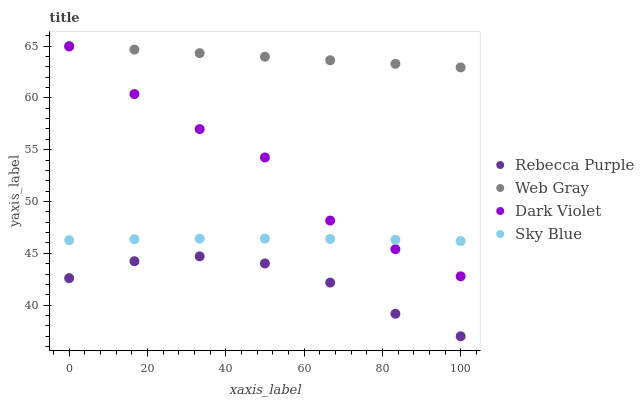Does Rebecca Purple have the minimum area under the curve?
Answer yes or no. Yes. Does Web Gray have the maximum area under the curve?
Answer yes or no. Yes. Does Web Gray have the minimum area under the curve?
Answer yes or no. No. Does Rebecca Purple have the maximum area under the curve?
Answer yes or no. No. Is Web Gray the smoothest?
Answer yes or no. Yes. Is Dark Violet the roughest?
Answer yes or no. Yes. Is Rebecca Purple the smoothest?
Answer yes or no. No. Is Rebecca Purple the roughest?
Answer yes or no. No. Does Rebecca Purple have the lowest value?
Answer yes or no. Yes. Does Web Gray have the lowest value?
Answer yes or no. No. Does Web Gray have the highest value?
Answer yes or no. Yes. Does Rebecca Purple have the highest value?
Answer yes or no. No. Is Rebecca Purple less than Web Gray?
Answer yes or no. Yes. Is Web Gray greater than Sky Blue?
Answer yes or no. Yes. Does Sky Blue intersect Dark Violet?
Answer yes or no. Yes. Is Sky Blue less than Dark Violet?
Answer yes or no. No. Is Sky Blue greater than Dark Violet?
Answer yes or no. No. Does Rebecca Purple intersect Web Gray?
Answer yes or no. No. 